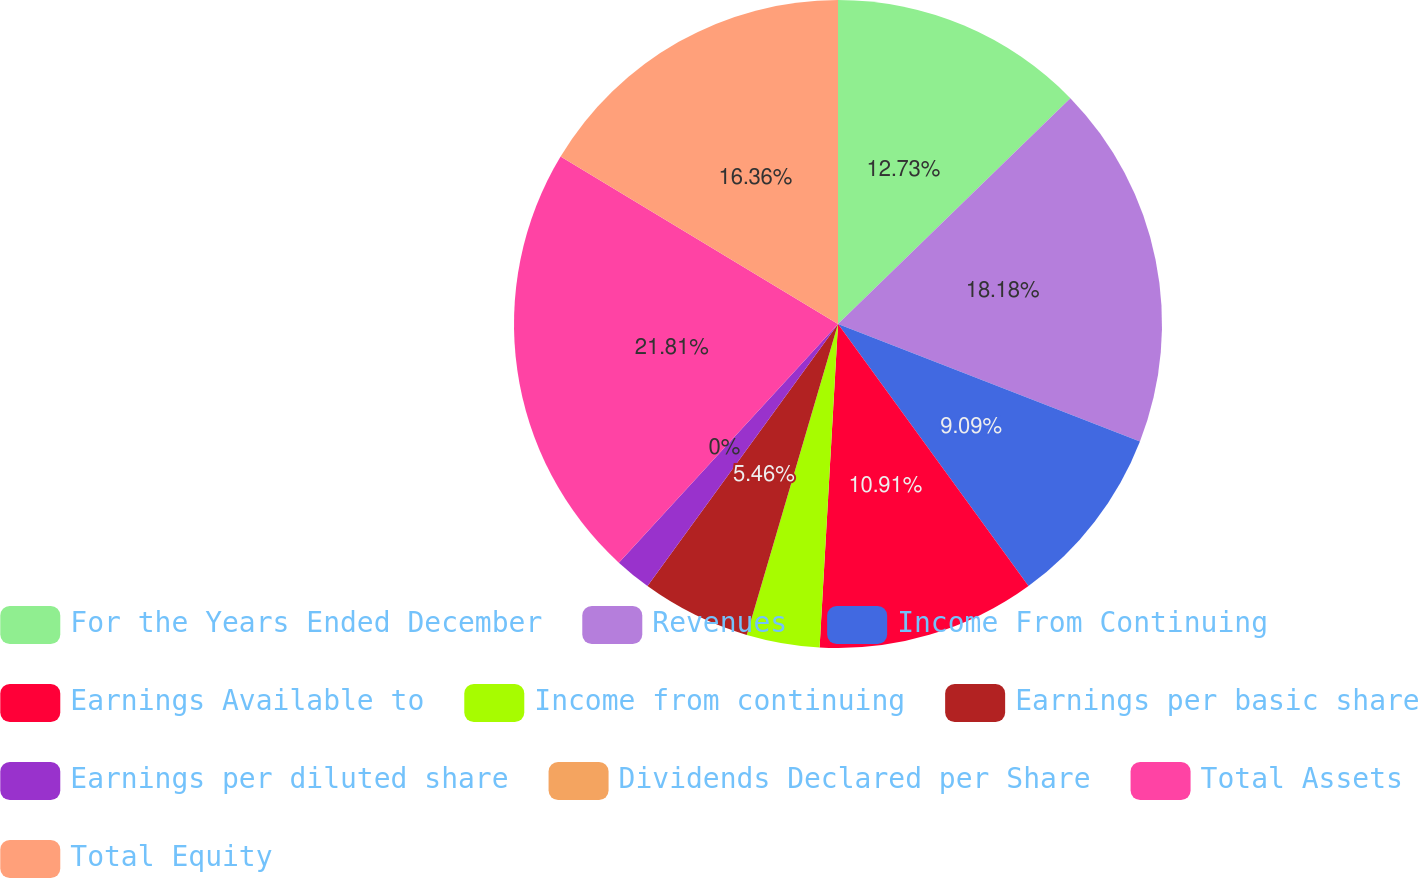Convert chart. <chart><loc_0><loc_0><loc_500><loc_500><pie_chart><fcel>For the Years Ended December<fcel>Revenues<fcel>Income From Continuing<fcel>Earnings Available to<fcel>Income from continuing<fcel>Earnings per basic share<fcel>Earnings per diluted share<fcel>Dividends Declared per Share<fcel>Total Assets<fcel>Total Equity<nl><fcel>12.73%<fcel>18.18%<fcel>9.09%<fcel>10.91%<fcel>3.64%<fcel>5.46%<fcel>1.82%<fcel>0.0%<fcel>21.82%<fcel>16.36%<nl></chart> 